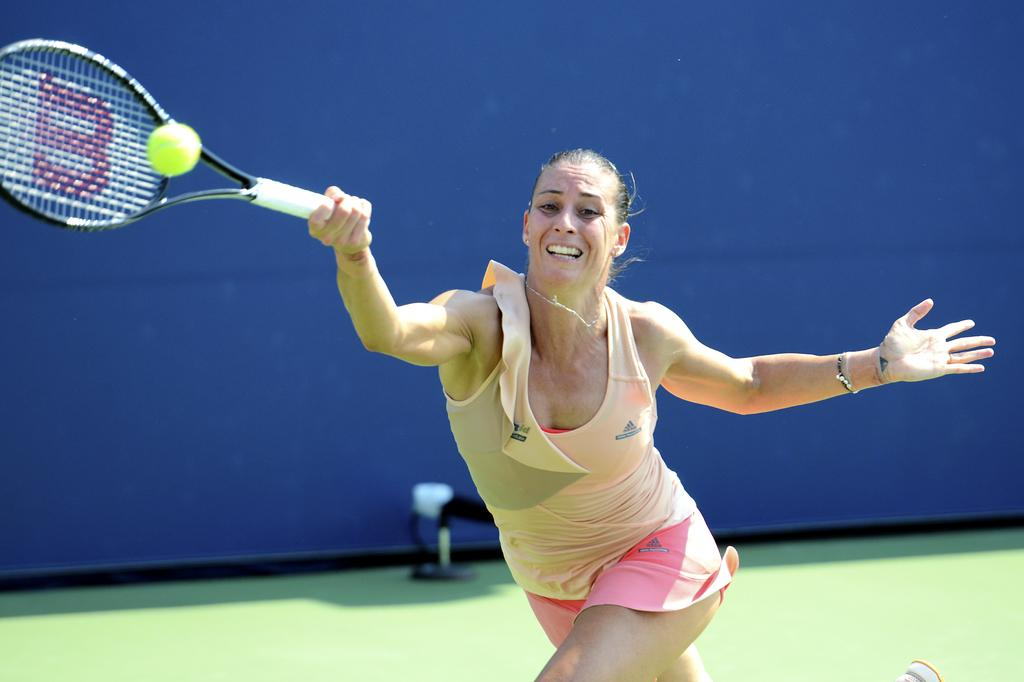What is the lady in the image doing? The lady is playing tennis. What object does the lady have in her hand? The lady has a tennis bat in her hand. What action is the lady about to perform? She is about to hit a tennis ball. What can be seen behind the lady in the image? There is a wall behind the lady. What type of kettle can be seen in the aftermath of the lady's tennis game? There is no kettle present in the image, and the term "aftermath" is not relevant to the scene depicted. 